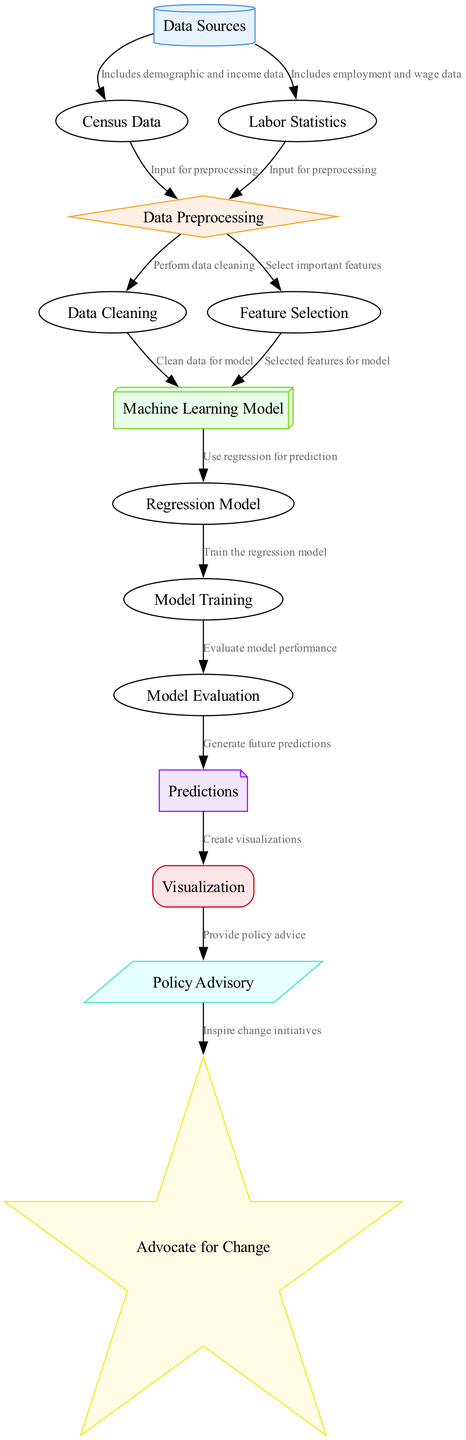What is the first node in the diagram? The first node in the diagram is connected to the "Data Sources" node, which serves as the starting point for input data.
Answer: Data Sources How many nodes are present in the diagram? By counting each unique node listed, we find there are a total of 14 nodes present in the diagram.
Answer: 14 Which nodes directly connect to the "Data Preprocessing" node? The nodes that directly connect to "Data Preprocessing" are "Census Data" and "Labor Statistics", as they both provide input data for preprocessing.
Answer: Census Data, Labor Statistics What is the purpose of the "Model Evaluation" node? The "Model Evaluation" node is responsible for assessing the performance and accuracy of the model after training, which is a critical step before making predictions.
Answer: Assess model accuracy and performance How do "Predictions" relate to "Visualization"? The "Predictions" node generates future income inequality trends, which are then represented graphically in the "Visualization" node, indicating a direct relationship in the flow.
Answer: Create visualizations Which node advocates for social change based on the findings? The "Advocate for Change" node is where findings from the model and policy advisory are used to inspire social justice initiatives to create change.
Answer: Advocate for Change What type of model is described in the "Machine Learning Model" node? The "Machine Learning Model" node refers to the use of a regression model specifically to predict income inequality trends in this context.
Answer: Regression Model What is the role of the "Policy Advisory" node in the diagram? The role of the "Policy Advisory" node is to provide recommendations for policy changes based on the visualized predictions, which can potentially guide effective interventions.
Answer: Provide policy advice What is the relationship between "Data Cleaning" and "Machine Learning Model"? "Data Cleaning" ensures that incomplete and erroneous records are rectified, which is essential for providing a clean dataset to the "Machine Learning Model" for accurate predictions.
Answer: Clean data for model 